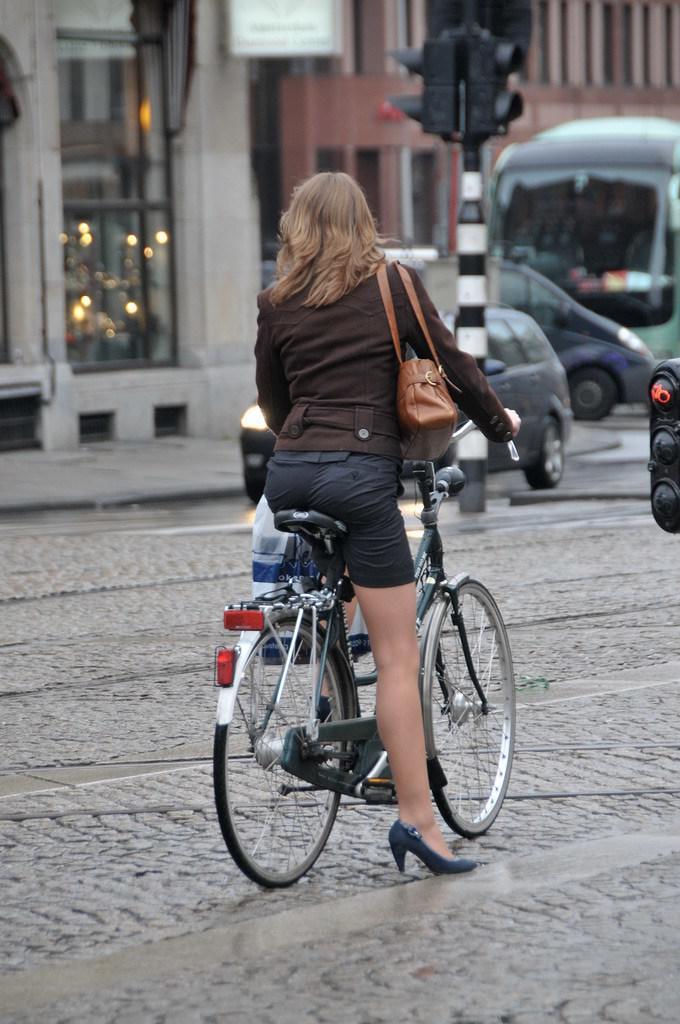In one or two sentences, can you explain what this image depicts? This picture describe about a woman who is wearing a brown jacket and small black skirt is riding a bicycle on the cobblestone, on the right side we can see a signal light. Opposite we can see a bus and vehicle passing through and big glass shop door and building beside it. 